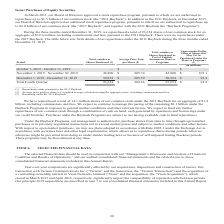According to American Tower Corporation's financial document, What do the company's Buyback Programs authorize the company to do? management is authorized to purchase shares from time to time through open market purchases or in privately negotiated transactions not to exceed market prices and subject to market conditions and other factors.. The document states: "Under the Buyback Programs, our management is authorized to purchase shares from time to time through open market purchases or in privately negotiated..." Also, During the fourth quarter 2019, how many shares of their common stock did the company purchase? According to the financial document, 93,654. The relevant text states: "nded December 31, 2019, we repurchased a total of 93,654 shares of our common stock for an aggregate of $19.6 million, including commissions and fees, pursu..." Also, How many shares were purchased in November? According to the financial document, 42,800. The relevant text states: "November 1, 2019 - November 30, 2019 42,800 $ 209.74 42,800 $ 103.1..." Also, can you calculate: What is the average of average price paid per share between November and December? To answer this question, I need to perform calculations using the financial data. The calculation is: ($209.74+$209.59)/2, which equals 209.67. This is based on the information: "December 1, 2019 - December 31, 2019 50,854 $ 209.59 50,854 $ 92.4 November 1, 2019 - November 30, 2019 42,800 $ 209.74 42,800 $ 103.1..." The key data points involved are: 209.59, 209.74. Also, can you calculate: What was the change in the total number of shares purchased between November and December? Based on the calculation: 50,854-42,800, the result is 8054 (in millions). This is based on the information: "December 1, 2019 - December 31, 2019 50,854 $ 209.59 50,854 $ 92.4 November 1, 2019 - November 30, 2019 42,800 $ 209.74 42,800 $ 103.1..." The key data points involved are: 42,800, 50,854. Also, can you calculate: What was the percentage change in the Approximate Dollar Value of Shares that May Yet be Purchased Under the Plans or Programs between November and December? To answer this question, I need to perform calculations using the financial data. The calculation is: ($92.4-$103.1)/$103.1, which equals -10.38 (percentage). This is based on the information: "2019 - December 31, 2019 50,854 $ 209.59 50,854 $ 92.4 2019 - November 30, 2019 42,800 $ 209.74 42,800 $ 103.1..." The key data points involved are: 103.1, 92.4. 